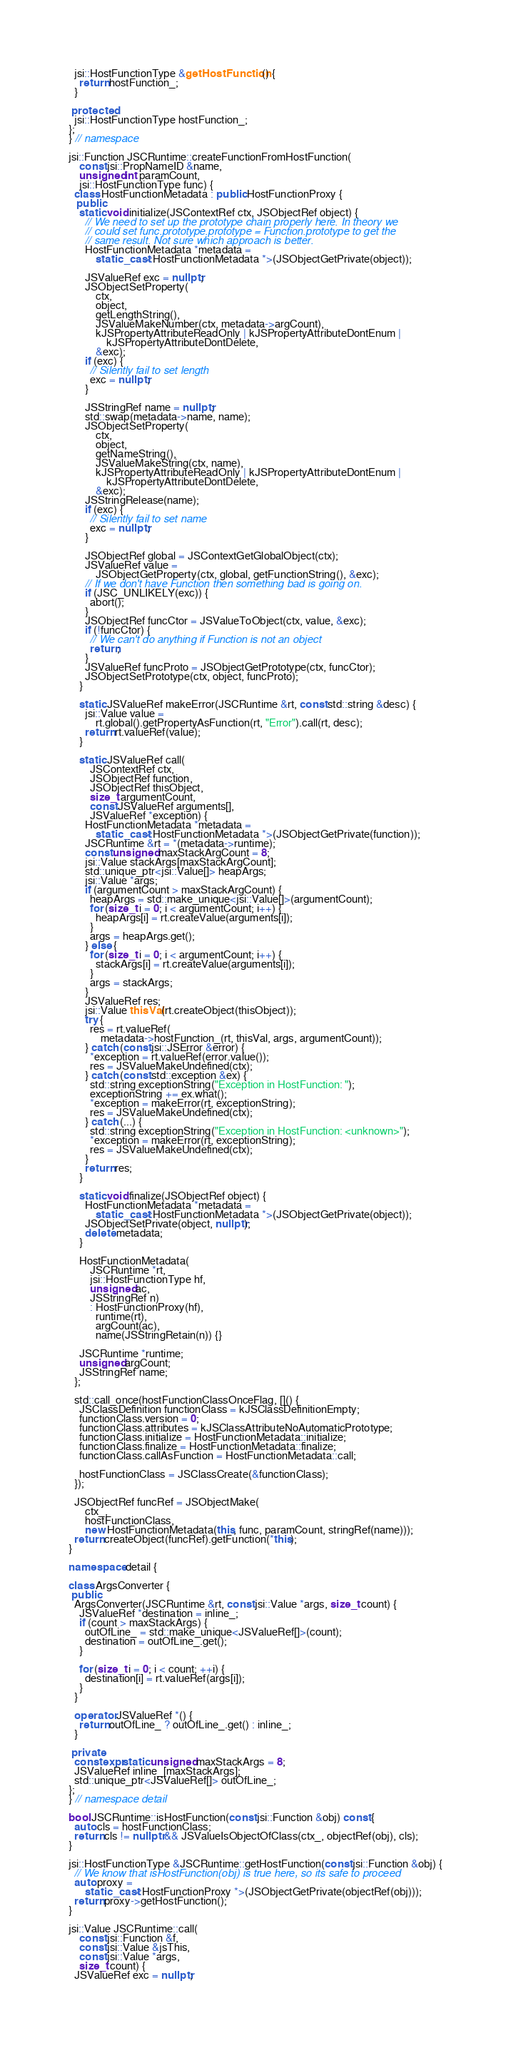<code> <loc_0><loc_0><loc_500><loc_500><_C++_>  jsi::HostFunctionType &getHostFunction() {
    return hostFunction_;
  }

 protected:
  jsi::HostFunctionType hostFunction_;
};
} // namespace

jsi::Function JSCRuntime::createFunctionFromHostFunction(
    const jsi::PropNameID &name,
    unsigned int paramCount,
    jsi::HostFunctionType func) {
  class HostFunctionMetadata : public HostFunctionProxy {
   public:
    static void initialize(JSContextRef ctx, JSObjectRef object) {
      // We need to set up the prototype chain properly here. In theory we
      // could set func.prototype.prototype = Function.prototype to get the
      // same result. Not sure which approach is better.
      HostFunctionMetadata *metadata =
          static_cast<HostFunctionMetadata *>(JSObjectGetPrivate(object));

      JSValueRef exc = nullptr;
      JSObjectSetProperty(
          ctx,
          object,
          getLengthString(),
          JSValueMakeNumber(ctx, metadata->argCount),
          kJSPropertyAttributeReadOnly | kJSPropertyAttributeDontEnum |
              kJSPropertyAttributeDontDelete,
          &exc);
      if (exc) {
        // Silently fail to set length
        exc = nullptr;
      }

      JSStringRef name = nullptr;
      std::swap(metadata->name, name);
      JSObjectSetProperty(
          ctx,
          object,
          getNameString(),
          JSValueMakeString(ctx, name),
          kJSPropertyAttributeReadOnly | kJSPropertyAttributeDontEnum |
              kJSPropertyAttributeDontDelete,
          &exc);
      JSStringRelease(name);
      if (exc) {
        // Silently fail to set name
        exc = nullptr;
      }

      JSObjectRef global = JSContextGetGlobalObject(ctx);
      JSValueRef value =
          JSObjectGetProperty(ctx, global, getFunctionString(), &exc);
      // If we don't have Function then something bad is going on.
      if (JSC_UNLIKELY(exc)) {
        abort();
      }
      JSObjectRef funcCtor = JSValueToObject(ctx, value, &exc);
      if (!funcCtor) {
        // We can't do anything if Function is not an object
        return;
      }
      JSValueRef funcProto = JSObjectGetPrototype(ctx, funcCtor);
      JSObjectSetPrototype(ctx, object, funcProto);
    }

    static JSValueRef makeError(JSCRuntime &rt, const std::string &desc) {
      jsi::Value value =
          rt.global().getPropertyAsFunction(rt, "Error").call(rt, desc);
      return rt.valueRef(value);
    }

    static JSValueRef call(
        JSContextRef ctx,
        JSObjectRef function,
        JSObjectRef thisObject,
        size_t argumentCount,
        const JSValueRef arguments[],
        JSValueRef *exception) {
      HostFunctionMetadata *metadata =
          static_cast<HostFunctionMetadata *>(JSObjectGetPrivate(function));
      JSCRuntime &rt = *(metadata->runtime);
      const unsigned maxStackArgCount = 8;
      jsi::Value stackArgs[maxStackArgCount];
      std::unique_ptr<jsi::Value[]> heapArgs;
      jsi::Value *args;
      if (argumentCount > maxStackArgCount) {
        heapArgs = std::make_unique<jsi::Value[]>(argumentCount);
        for (size_t i = 0; i < argumentCount; i++) {
          heapArgs[i] = rt.createValue(arguments[i]);
        }
        args = heapArgs.get();
      } else {
        for (size_t i = 0; i < argumentCount; i++) {
          stackArgs[i] = rt.createValue(arguments[i]);
        }
        args = stackArgs;
      }
      JSValueRef res;
      jsi::Value thisVal(rt.createObject(thisObject));
      try {
        res = rt.valueRef(
            metadata->hostFunction_(rt, thisVal, args, argumentCount));
      } catch (const jsi::JSError &error) {
        *exception = rt.valueRef(error.value());
        res = JSValueMakeUndefined(ctx);
      } catch (const std::exception &ex) {
        std::string exceptionString("Exception in HostFunction: ");
        exceptionString += ex.what();
        *exception = makeError(rt, exceptionString);
        res = JSValueMakeUndefined(ctx);
      } catch (...) {
        std::string exceptionString("Exception in HostFunction: <unknown>");
        *exception = makeError(rt, exceptionString);
        res = JSValueMakeUndefined(ctx);
      }
      return res;
    }

    static void finalize(JSObjectRef object) {
      HostFunctionMetadata *metadata =
          static_cast<HostFunctionMetadata *>(JSObjectGetPrivate(object));
      JSObjectSetPrivate(object, nullptr);
      delete metadata;
    }

    HostFunctionMetadata(
        JSCRuntime *rt,
        jsi::HostFunctionType hf,
        unsigned ac,
        JSStringRef n)
        : HostFunctionProxy(hf),
          runtime(rt),
          argCount(ac),
          name(JSStringRetain(n)) {}

    JSCRuntime *runtime;
    unsigned argCount;
    JSStringRef name;
  };

  std::call_once(hostFunctionClassOnceFlag, []() {
    JSClassDefinition functionClass = kJSClassDefinitionEmpty;
    functionClass.version = 0;
    functionClass.attributes = kJSClassAttributeNoAutomaticPrototype;
    functionClass.initialize = HostFunctionMetadata::initialize;
    functionClass.finalize = HostFunctionMetadata::finalize;
    functionClass.callAsFunction = HostFunctionMetadata::call;

    hostFunctionClass = JSClassCreate(&functionClass);
  });

  JSObjectRef funcRef = JSObjectMake(
      ctx_,
      hostFunctionClass,
      new HostFunctionMetadata(this, func, paramCount, stringRef(name)));
  return createObject(funcRef).getFunction(*this);
}

namespace detail {

class ArgsConverter {
 public:
  ArgsConverter(JSCRuntime &rt, const jsi::Value *args, size_t count) {
    JSValueRef *destination = inline_;
    if (count > maxStackArgs) {
      outOfLine_ = std::make_unique<JSValueRef[]>(count);
      destination = outOfLine_.get();
    }

    for (size_t i = 0; i < count; ++i) {
      destination[i] = rt.valueRef(args[i]);
    }
  }

  operator JSValueRef *() {
    return outOfLine_ ? outOfLine_.get() : inline_;
  }

 private:
  constexpr static unsigned maxStackArgs = 8;
  JSValueRef inline_[maxStackArgs];
  std::unique_ptr<JSValueRef[]> outOfLine_;
};
} // namespace detail

bool JSCRuntime::isHostFunction(const jsi::Function &obj) const {
  auto cls = hostFunctionClass;
  return cls != nullptr && JSValueIsObjectOfClass(ctx_, objectRef(obj), cls);
}

jsi::HostFunctionType &JSCRuntime::getHostFunction(const jsi::Function &obj) {
  // We know that isHostFunction(obj) is true here, so its safe to proceed
  auto proxy =
      static_cast<HostFunctionProxy *>(JSObjectGetPrivate(objectRef(obj)));
  return proxy->getHostFunction();
}

jsi::Value JSCRuntime::call(
    const jsi::Function &f,
    const jsi::Value &jsThis,
    const jsi::Value *args,
    size_t count) {
  JSValueRef exc = nullptr;</code> 